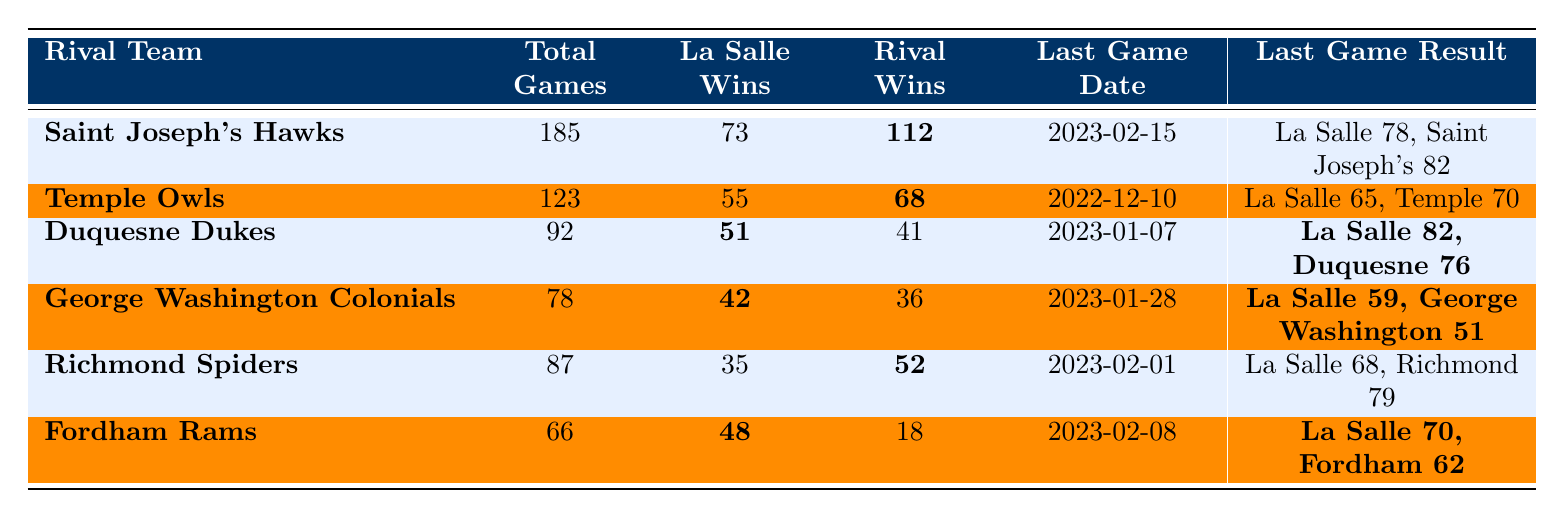What's the total number of games played against the Saint Joseph's Hawks? The table lists "Total Games" for the Saint Joseph's Hawks as 185.
Answer: 185 How many wins does La Salle have against the Temple Owls? La Salle’s wins against the Temple Owls are noted in the table as 55.
Answer: 55 What was the result of the last game played against the Duquesne Dukes? The last game result against Duquesne Dukes is given as "La Salle 82, Duquesne 76."
Answer: La Salle 82, Duquesne 76 Which rival team has the most wins against La Salle? The "Rival Wins" column for the Saint Joseph's Hawks shows the highest value at 112.
Answer: Saint Joseph's Hawks How many more wins does the Temple Owls have over La Salle? Temple Owls have 68 wins, La Salle has 55 wins. The difference is 68 - 55 = 13.
Answer: 13 What percentage of games has La Salle won against the Fordham Rams? La Salle has 48 wins out of 66 total games. To calculate the percentage: (48/66) * 100 ≈ 72.73%.
Answer: 72.73% Is the last game against the Richmond Spiders won by La Salle? The last game result is "La Salle 68, Richmond 79", indicating that La Salle lost.
Answer: No How many teams does La Salle have more wins against compared to losses? La Salle has more wins against the Duquesne Dukes and Fordham Rams (51 vs 41 and 48 vs 18, respectively). That totals 2 teams.
Answer: 2 What is the average number of wins La Salle has against its rivals based on the table? The wins are: 73, 55, 51, 42, 35, 48. The average is (73 + 55 + 51 + 42 + 35 + 48) / 6 = 50.67.
Answer: 50.67 Which rival team did La Salle last defeat, according to the table? The last recorded result indicates La Salle defeated Fordham Rams with a score of "La Salle 70, Fordham 62" on February 8, 2023.
Answer: Fordham Rams 